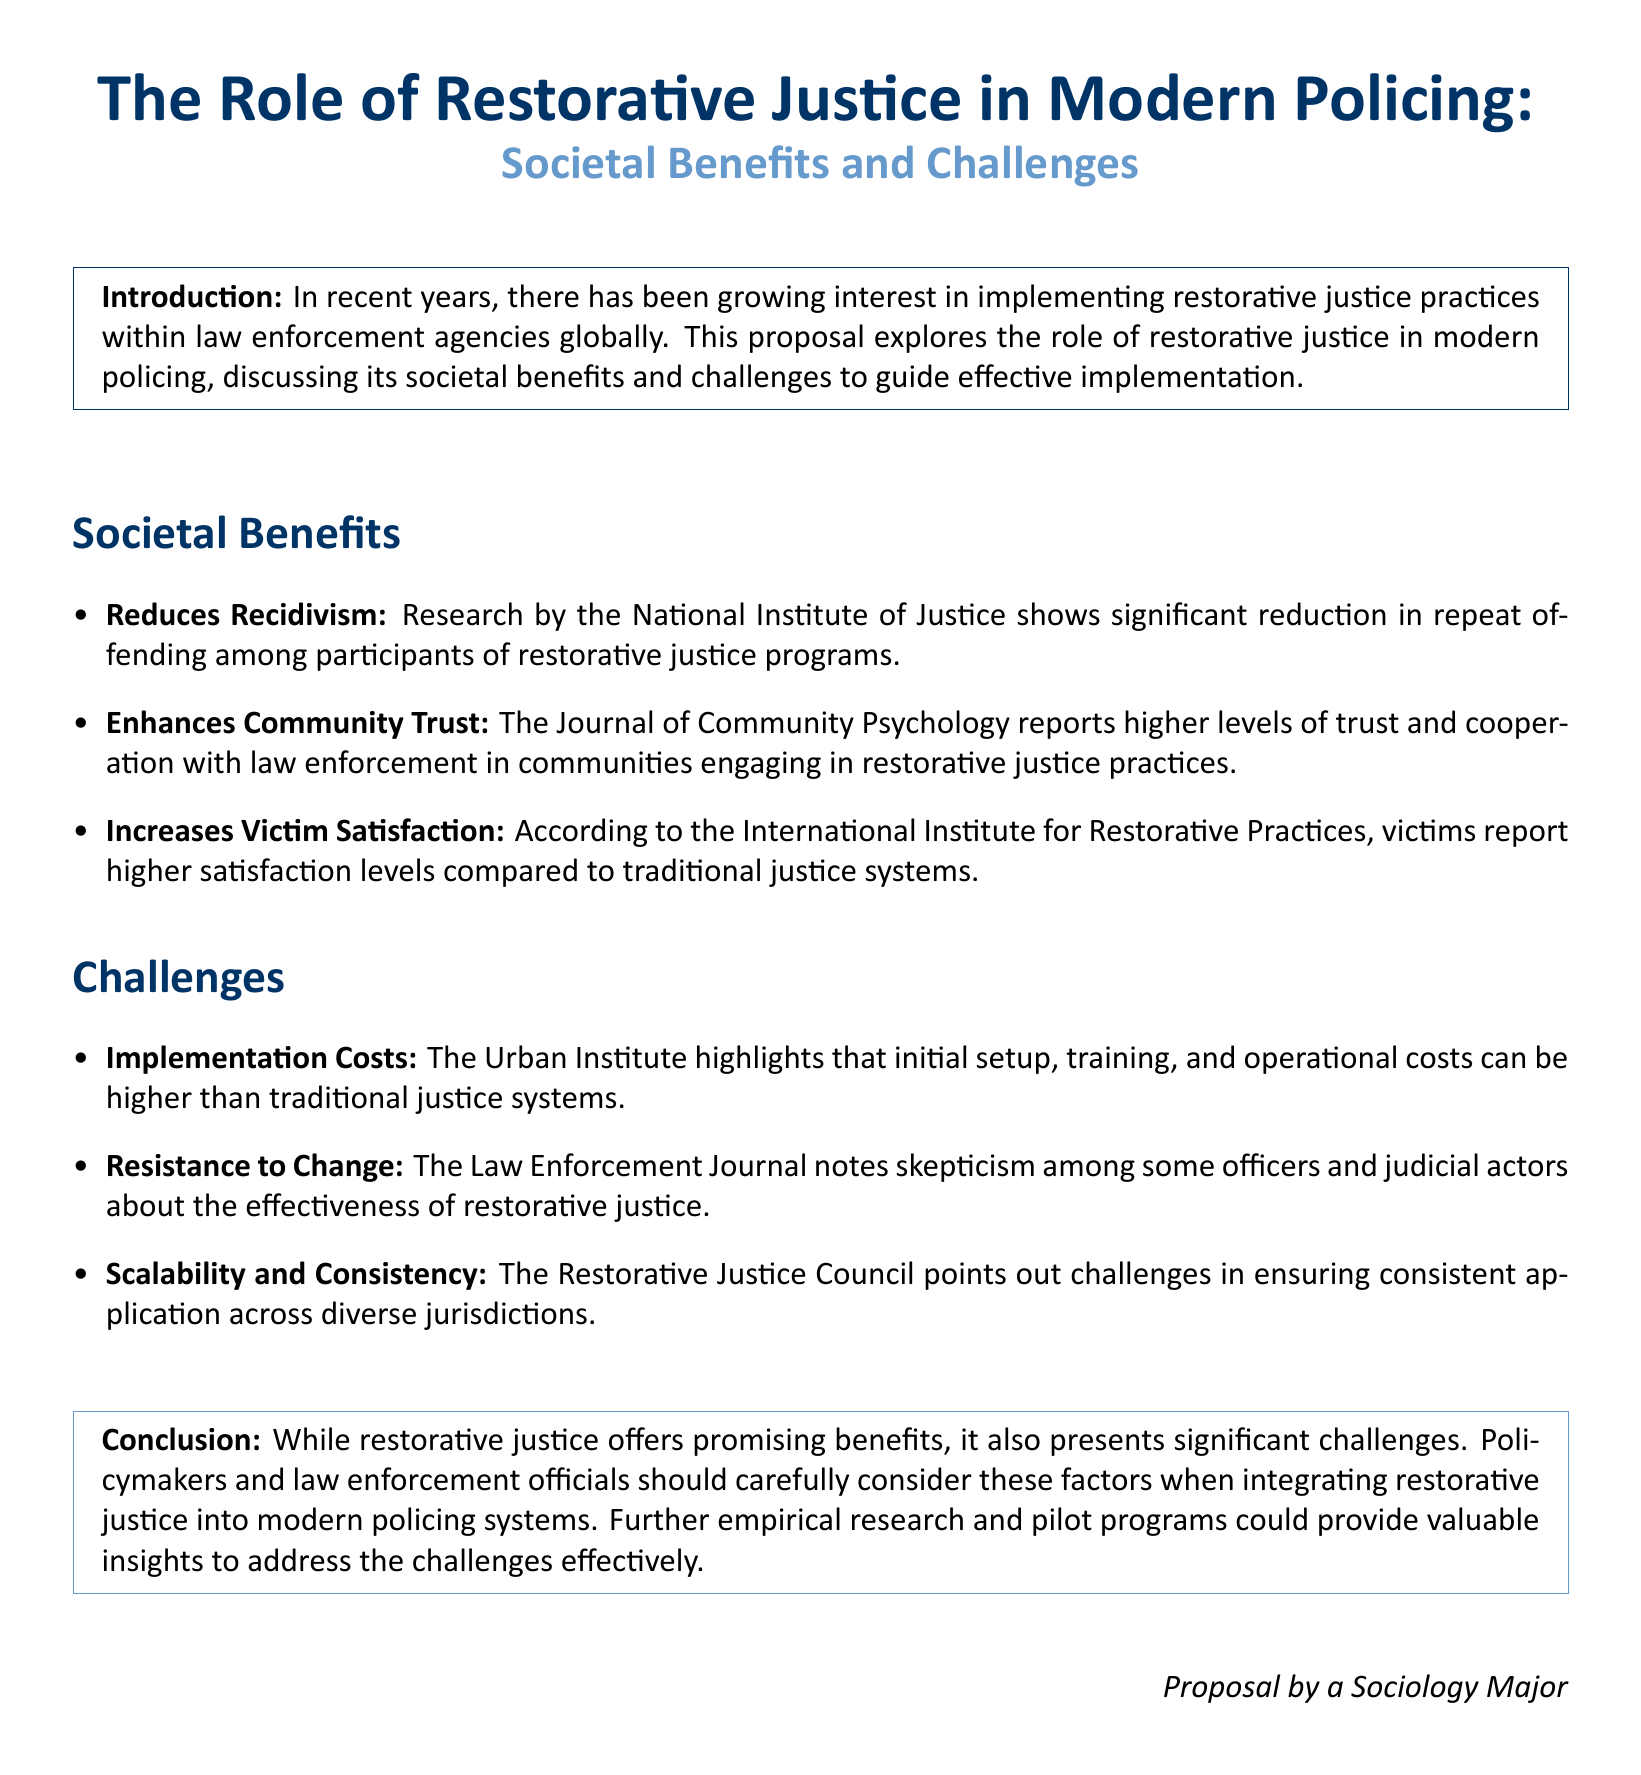What is the main focus of the proposal? The main focus of the proposal is on restorative justice practices within law enforcement agencies.
Answer: Restorative justice practices Which organization shows a significant reduction in repeat offending? The National Institute of Justice is cited in the document as showing reduction in repeat offending.
Answer: National Institute of Justice What do victims report regarding their satisfaction levels in restorative justice programs? According to the International Institute for Restorative Practices, victims report higher satisfaction levels in restorative justice programs.
Answer: Higher satisfaction levels What challenge is associated with the initial setup of restorative justice? The Urban Institute highlights that implementation costs can be higher than traditional justice systems.
Answer: Implementation costs What does the Law Enforcement Journal note about officers' perceptions? The Law Enforcement Journal notes skepticism among some officers regarding restorative justice effectiveness.
Answer: Skepticism In which section of the proposal are societal benefits discussed? Societal benefits are discussed in the "Societal Benefits" section of the proposal.
Answer: Societal Benefits What is suggested for policymakers and law enforcement officials regarding restorative justice? The conclusion suggests that policymakers should carefully consider the factors when integrating restorative justice.
Answer: Carefully consider factors Which organization emphasizes challenges in application consistency? The Restorative Justice Council points out challenges in ensuring consistent application across jurisdictions.
Answer: Restorative Justice Council 